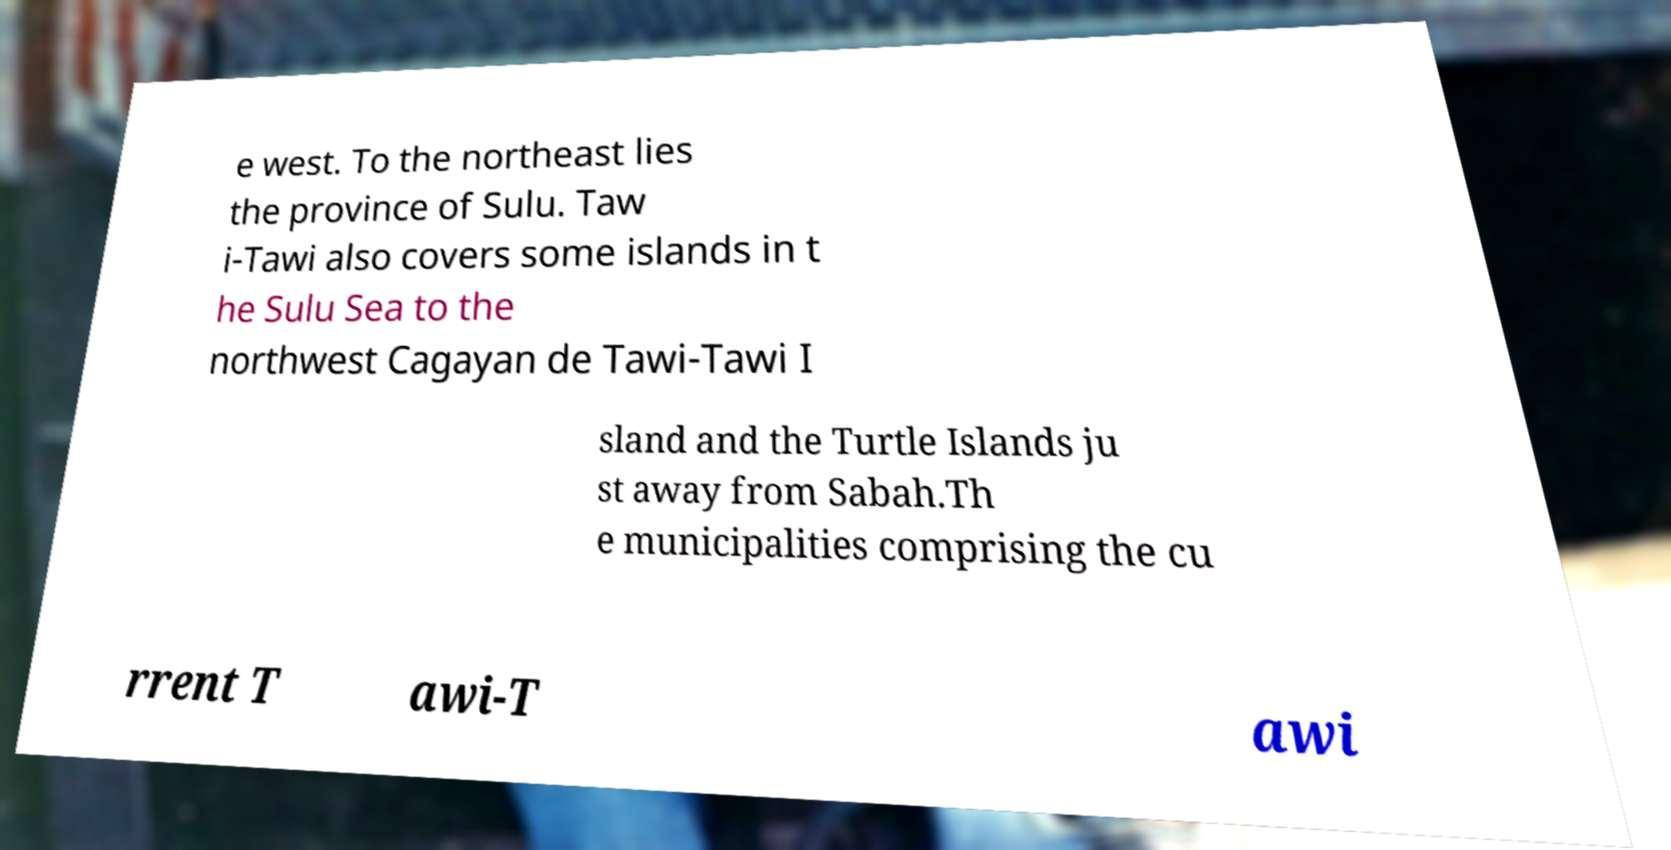Could you extract and type out the text from this image? e west. To the northeast lies the province of Sulu. Taw i-Tawi also covers some islands in t he Sulu Sea to the northwest Cagayan de Tawi-Tawi I sland and the Turtle Islands ju st away from Sabah.Th e municipalities comprising the cu rrent T awi-T awi 